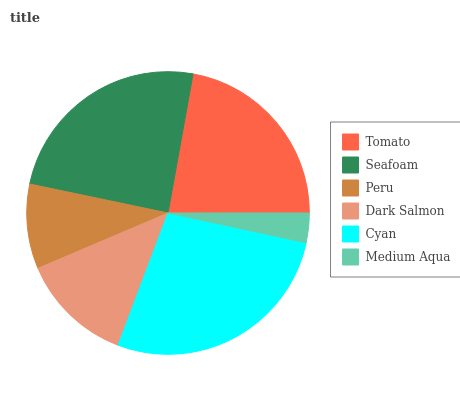Is Medium Aqua the minimum?
Answer yes or no. Yes. Is Cyan the maximum?
Answer yes or no. Yes. Is Seafoam the minimum?
Answer yes or no. No. Is Seafoam the maximum?
Answer yes or no. No. Is Seafoam greater than Tomato?
Answer yes or no. Yes. Is Tomato less than Seafoam?
Answer yes or no. Yes. Is Tomato greater than Seafoam?
Answer yes or no. No. Is Seafoam less than Tomato?
Answer yes or no. No. Is Tomato the high median?
Answer yes or no. Yes. Is Dark Salmon the low median?
Answer yes or no. Yes. Is Seafoam the high median?
Answer yes or no. No. Is Peru the low median?
Answer yes or no. No. 